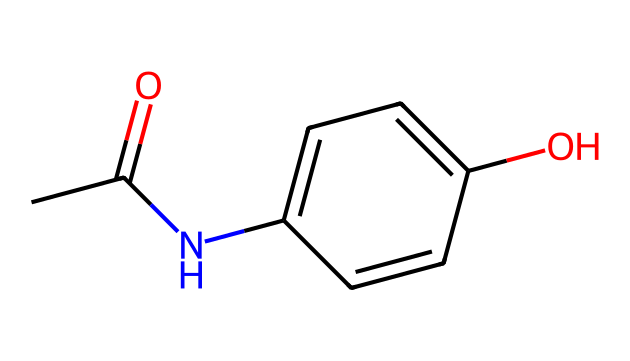What is the molecular formula of acetaminophen? By analyzing the SMILES representation, we can count the types of atoms present. The structure indicates there are 8 carbon (C) atoms, 9 hydrogen (H) atoms, 1 nitrogen (N) atom, and 1 oxygen (O) atom, leading to the molecular formula C8H9NO2.
Answer: C8H9NO2 How many rings are present in the structure? The SMILES representation shows that the chemical includes a benzene ring (indicated by the presence of 'c' characters representing aromatic carbon atoms), which suggests that there is 1 ring in the structure.
Answer: 1 What functional groups are present in acetaminophen? Upon examining the SMILES, we can identify the functional groups present: an amide (indicated by 'N' connected to 'C(=O)') and a phenolic hydroxyl group (indicated by 'O' connected to a carbon in the 'c' ring).
Answer: amide and hydroxyl How many hydrogen atoms are attached to carbon atoms in acetaminophen? In the SMILES representation, we can deduce that there are a total of 9 hydrogen atoms in the structure, as shown by both the terminal and the benzene ring structures with substituents.
Answer: 9 Does acetaminophen contain an asymmetric carbon? By analyzing the structure, there are no carbon atoms in the SMILES that have four different substituents; hence, acetaminophen does not have an asymmetric carbon.
Answer: no 